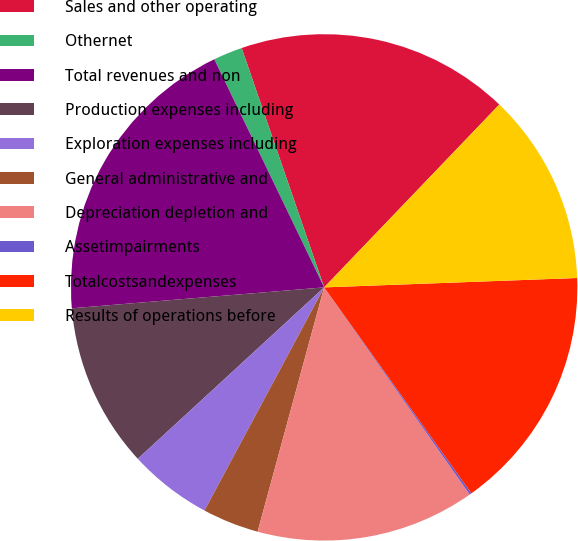<chart> <loc_0><loc_0><loc_500><loc_500><pie_chart><fcel>Sales and other operating<fcel>Othernet<fcel>Total revenues and non<fcel>Production expenses including<fcel>Exploration expenses including<fcel>General administrative and<fcel>Depreciation depletion and<fcel>Assetimpairments<fcel>Totalcostsandexpenses<fcel>Results of operations before<nl><fcel>17.44%<fcel>1.86%<fcel>19.17%<fcel>10.52%<fcel>5.33%<fcel>3.6%<fcel>13.98%<fcel>0.13%<fcel>15.71%<fcel>12.25%<nl></chart> 